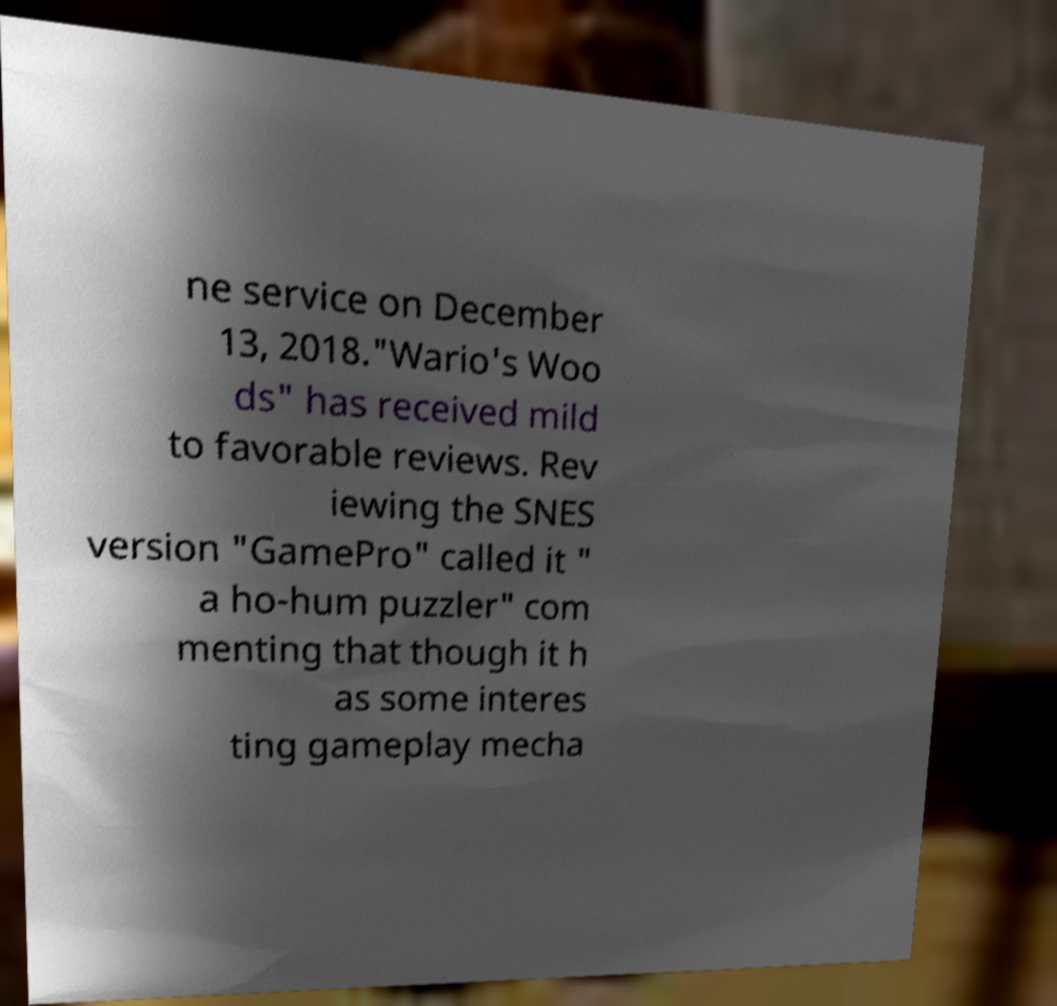Can you accurately transcribe the text from the provided image for me? ne service on December 13, 2018."Wario's Woo ds" has received mild to favorable reviews. Rev iewing the SNES version "GamePro" called it " a ho-hum puzzler" com menting that though it h as some interes ting gameplay mecha 